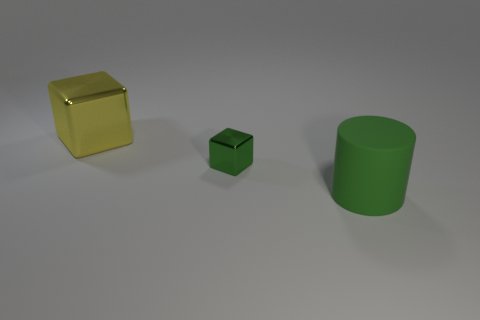Are there any other things that are the same size as the green shiny thing?
Offer a terse response. No. What number of big cubes are on the right side of the large metallic block?
Your answer should be compact. 0. Is the large object in front of the tiny green object made of the same material as the cube in front of the large shiny block?
Give a very brief answer. No. What shape is the metal object that is left of the cube that is right of the yellow metallic thing behind the small green block?
Offer a terse response. Cube. What is the shape of the green metal thing?
Your answer should be very brief. Cube. The green thing that is the same size as the yellow metal block is what shape?
Offer a very short reply. Cylinder. What number of other things are there of the same color as the large metallic object?
Your response must be concise. 0. There is a big thing right of the yellow metal cube; is it the same shape as the green object that is to the left of the large matte object?
Your answer should be compact. No. What number of things are either shiny cubes that are in front of the large yellow thing or tiny green things in front of the large yellow shiny block?
Your response must be concise. 1. What number of other objects are the same material as the green cylinder?
Offer a very short reply. 0. 